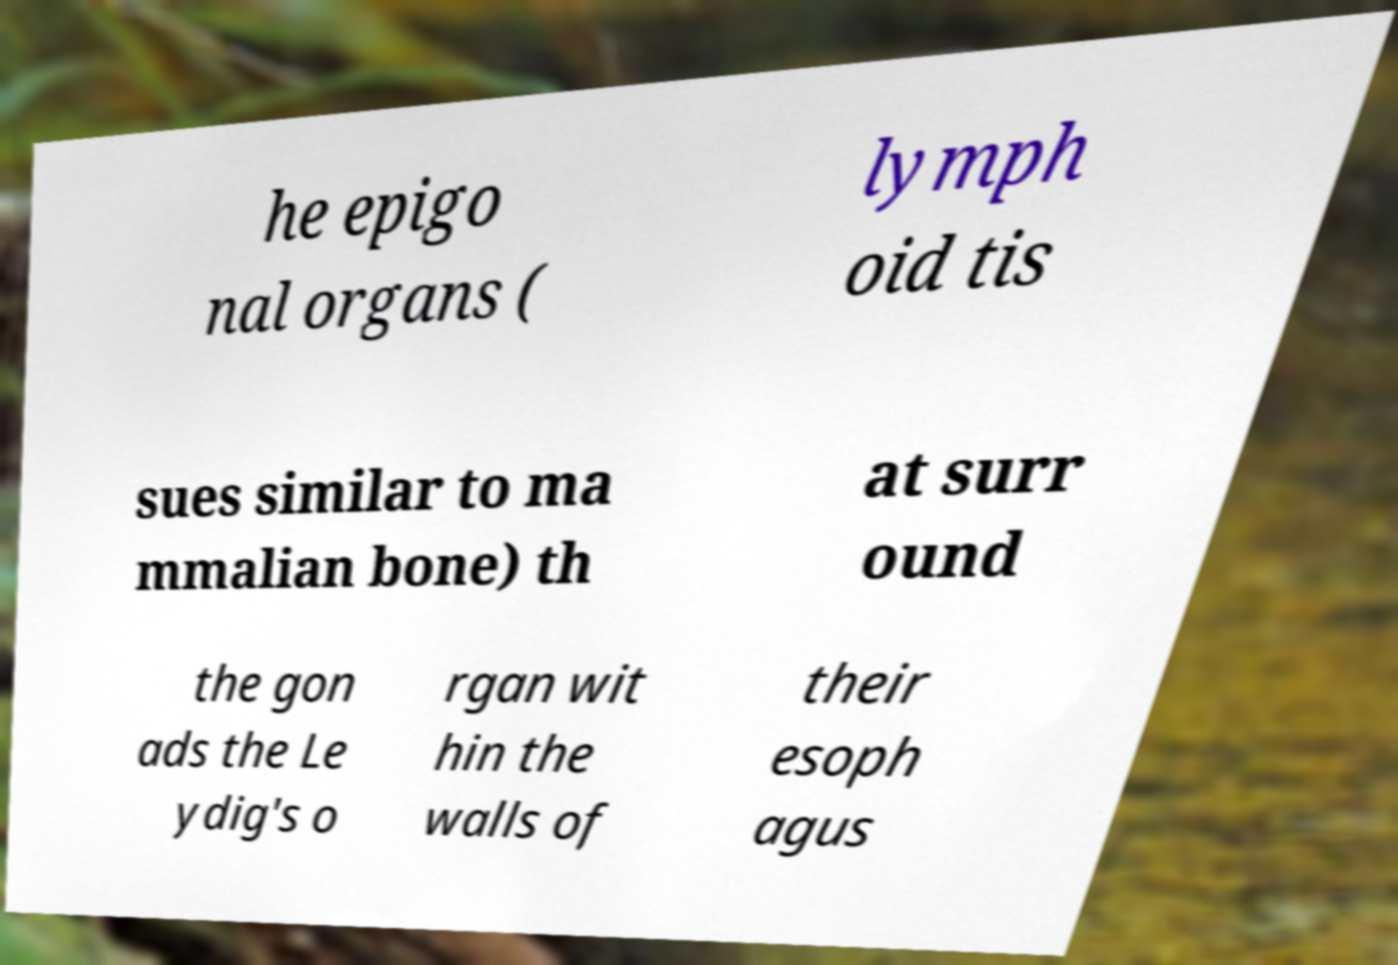Can you read and provide the text displayed in the image?This photo seems to have some interesting text. Can you extract and type it out for me? he epigo nal organs ( lymph oid tis sues similar to ma mmalian bone) th at surr ound the gon ads the Le ydig's o rgan wit hin the walls of their esoph agus 